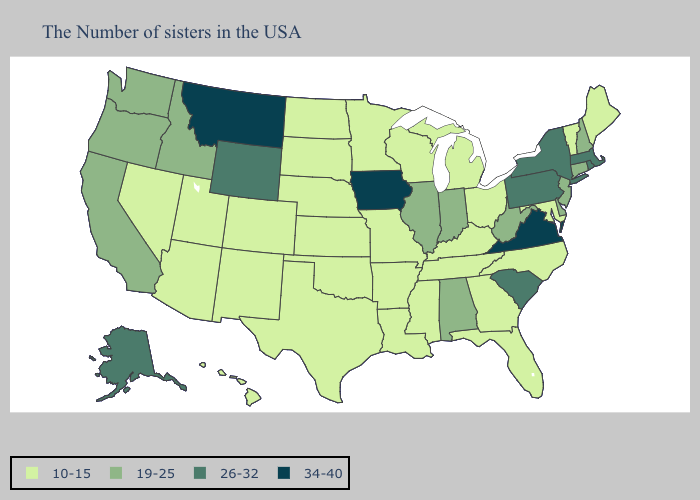Which states hav the highest value in the Northeast?
Keep it brief. Massachusetts, Rhode Island, New York, Pennsylvania. What is the highest value in the Northeast ?
Give a very brief answer. 26-32. Does Utah have a higher value than Nevada?
Keep it brief. No. What is the value of Hawaii?
Be succinct. 10-15. Does Pennsylvania have a lower value than Alaska?
Keep it brief. No. Name the states that have a value in the range 34-40?
Write a very short answer. Virginia, Iowa, Montana. What is the value of Hawaii?
Answer briefly. 10-15. Does Montana have the highest value in the West?
Give a very brief answer. Yes. What is the lowest value in the South?
Be succinct. 10-15. Does the first symbol in the legend represent the smallest category?
Keep it brief. Yes. Name the states that have a value in the range 19-25?
Short answer required. New Hampshire, Connecticut, New Jersey, Delaware, West Virginia, Indiana, Alabama, Illinois, Idaho, California, Washington, Oregon. What is the value of Hawaii?
Concise answer only. 10-15. Name the states that have a value in the range 19-25?
Answer briefly. New Hampshire, Connecticut, New Jersey, Delaware, West Virginia, Indiana, Alabama, Illinois, Idaho, California, Washington, Oregon. What is the highest value in the USA?
Answer briefly. 34-40. 